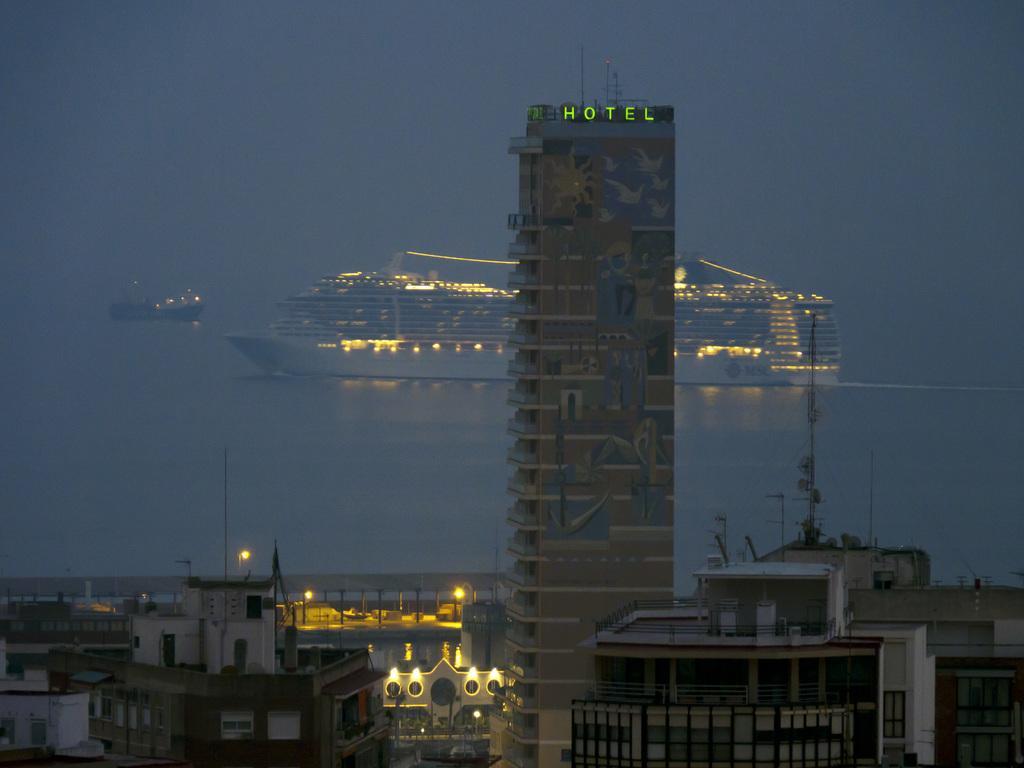Could you give a brief overview of what you see in this image? In this picture I can see there are a few buildings and there is a multi storied building. There are a ship and boat in the backdrop. The sky is foggy. 